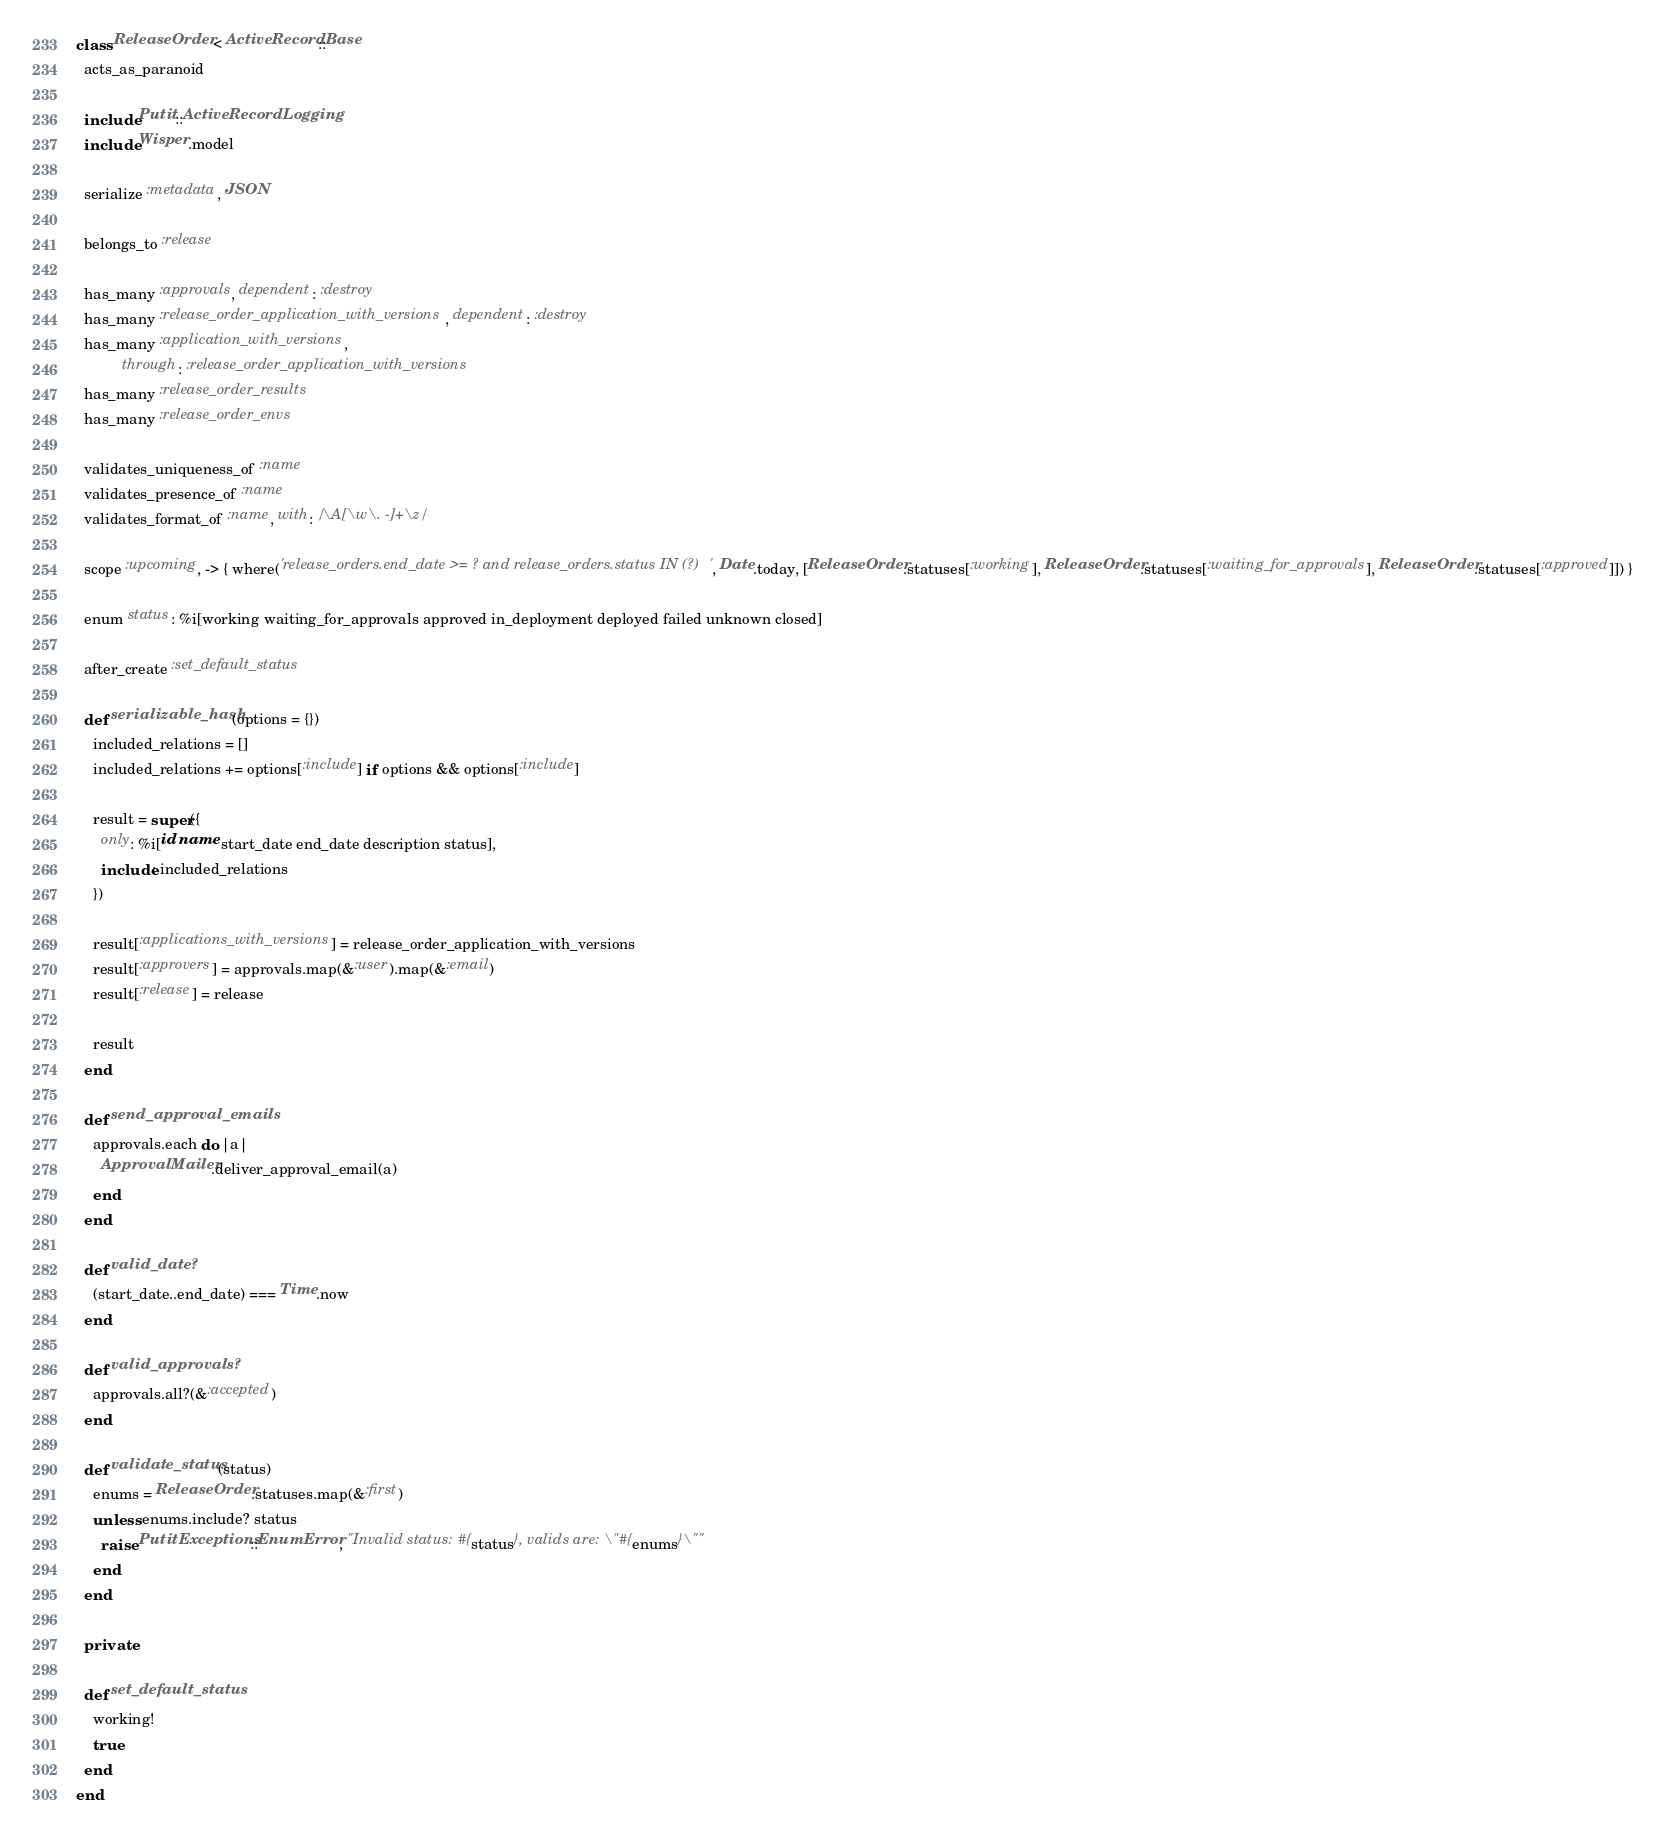Convert code to text. <code><loc_0><loc_0><loc_500><loc_500><_Ruby_>class ReleaseOrder < ActiveRecord::Base
  acts_as_paranoid

  include Putit::ActiveRecordLogging
  include Wisper.model

  serialize :metadata, JSON

  belongs_to :release

  has_many :approvals, dependent: :destroy
  has_many :release_order_application_with_versions, dependent: :destroy
  has_many :application_with_versions,
           through: :release_order_application_with_versions
  has_many :release_order_results
  has_many :release_order_envs

  validates_uniqueness_of :name
  validates_presence_of :name
  validates_format_of :name, with: /\A[\w\. -]+\z/

  scope :upcoming, -> { where('release_orders.end_date >= ? and release_orders.status IN (?)', Date.today, [ReleaseOrder.statuses[:working], ReleaseOrder.statuses[:waiting_for_approvals], ReleaseOrder.statuses[:approved]]) }

  enum status: %i[working waiting_for_approvals approved in_deployment deployed failed unknown closed]

  after_create :set_default_status

  def serializable_hash(options = {})
    included_relations = []
    included_relations += options[:include] if options && options[:include]

    result = super({
      only: %i[id name start_date end_date description status],
      include: included_relations
    })

    result[:applications_with_versions] = release_order_application_with_versions
    result[:approvers] = approvals.map(&:user).map(&:email)
    result[:release] = release

    result
  end

  def send_approval_emails
    approvals.each do |a|
      ApprovalMailer.deliver_approval_email(a)
    end
  end

  def valid_date?
    (start_date..end_date) === Time.now
  end

  def valid_approvals?
    approvals.all?(&:accepted)
  end

  def validate_status(status)
    enums = ReleaseOrder.statuses.map(&:first)
    unless enums.include? status
      raise PutitExceptions::EnumError, "Invalid status: #{status}, valids are: \"#{enums}\""
    end
  end

  private

  def set_default_status
    working!
    true
  end
end
</code> 